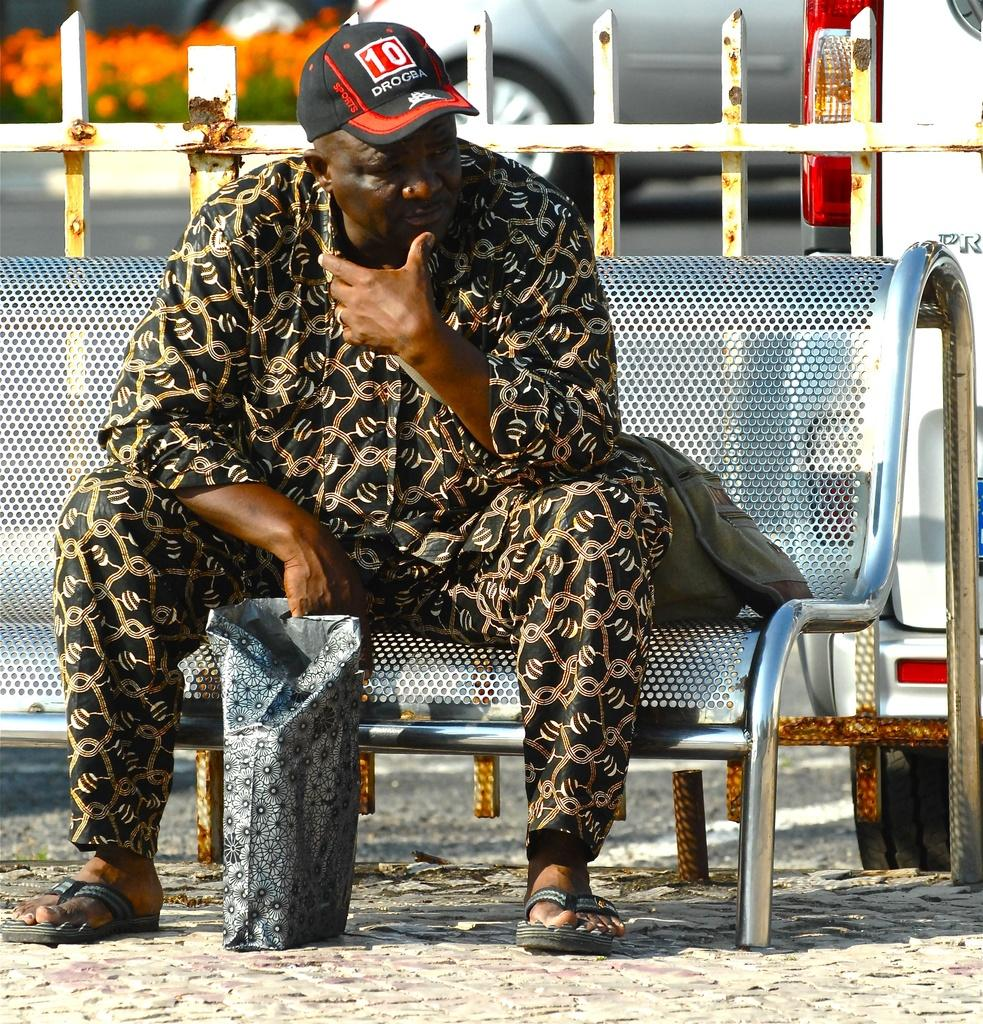Who is present in the image? There is a man in the image. What is the man wearing on his head? The man is wearing a cap. What is the man doing in the image? The man is sitting on a bench. What can be seen in the background of the image? There is a car, plants, and flowers in the background of the image. What type of zephyr can be seen blowing through the flowers in the image? There is no zephyr present in the image; it is a still image with no movement or wind. 